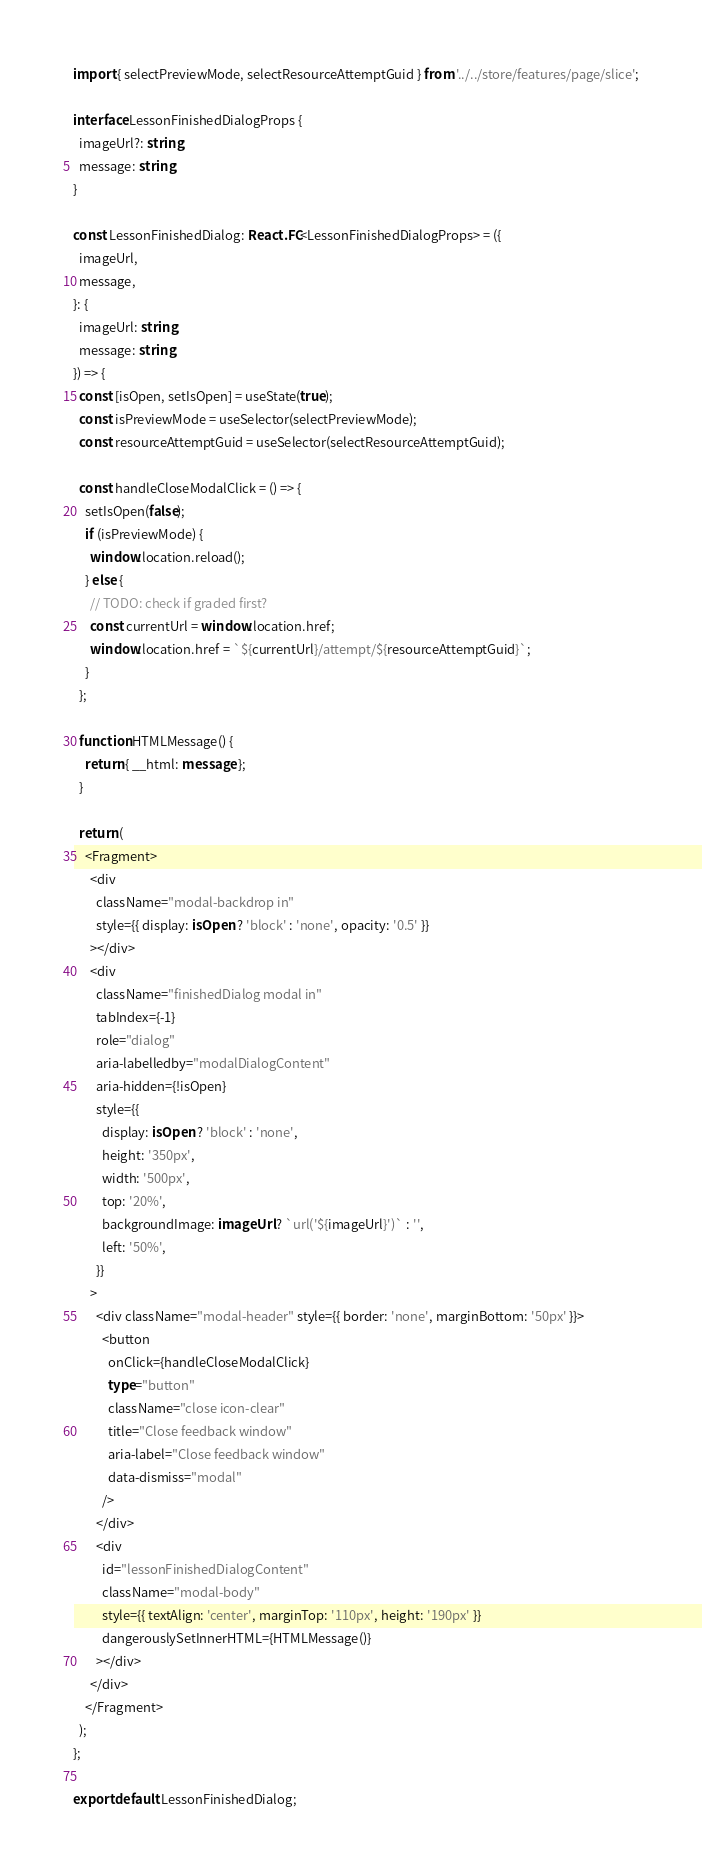Convert code to text. <code><loc_0><loc_0><loc_500><loc_500><_TypeScript_>import { selectPreviewMode, selectResourceAttemptGuid } from '../../store/features/page/slice';

interface LessonFinishedDialogProps {
  imageUrl?: string;
  message: string;
}

const LessonFinishedDialog: React.FC<LessonFinishedDialogProps> = ({
  imageUrl,
  message,
}: {
  imageUrl: string;
  message: string;
}) => {
  const [isOpen, setIsOpen] = useState(true);
  const isPreviewMode = useSelector(selectPreviewMode);
  const resourceAttemptGuid = useSelector(selectResourceAttemptGuid);

  const handleCloseModalClick = () => {
    setIsOpen(false);
    if (isPreviewMode) {
      window.location.reload();
    } else {
      // TODO: check if graded first?
      const currentUrl = window.location.href;
      window.location.href = `${currentUrl}/attempt/${resourceAttemptGuid}`;
    }
  };

  function HTMLMessage() {
    return { __html: message };
  }

  return (
    <Fragment>
      <div
        className="modal-backdrop in"
        style={{ display: isOpen ? 'block' : 'none', opacity: '0.5' }}
      ></div>
      <div
        className="finishedDialog modal in"
        tabIndex={-1}
        role="dialog"
        aria-labelledby="modalDialogContent"
        aria-hidden={!isOpen}
        style={{
          display: isOpen ? 'block' : 'none',
          height: '350px',
          width: '500px',
          top: '20%',
          backgroundImage: imageUrl ? `url('${imageUrl}')` : '',
          left: '50%',
        }}
      >
        <div className="modal-header" style={{ border: 'none', marginBottom: '50px' }}>
          <button
            onClick={handleCloseModalClick}
            type="button"
            className="close icon-clear"
            title="Close feedback window"
            aria-label="Close feedback window"
            data-dismiss="modal"
          />
        </div>
        <div
          id="lessonFinishedDialogContent"
          className="modal-body"
          style={{ textAlign: 'center', marginTop: '110px', height: '190px' }}
          dangerouslySetInnerHTML={HTMLMessage()}
        ></div>
      </div>
    </Fragment>
  );
};

export default LessonFinishedDialog;
</code> 